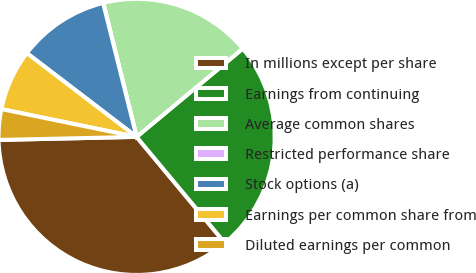<chart> <loc_0><loc_0><loc_500><loc_500><pie_chart><fcel>In millions except per share<fcel>Earnings from continuing<fcel>Average common shares<fcel>Restricted performance share<fcel>Stock options (a)<fcel>Earnings per common share from<fcel>Diluted earnings per common<nl><fcel>35.69%<fcel>24.99%<fcel>17.85%<fcel>0.01%<fcel>10.72%<fcel>7.15%<fcel>3.58%<nl></chart> 